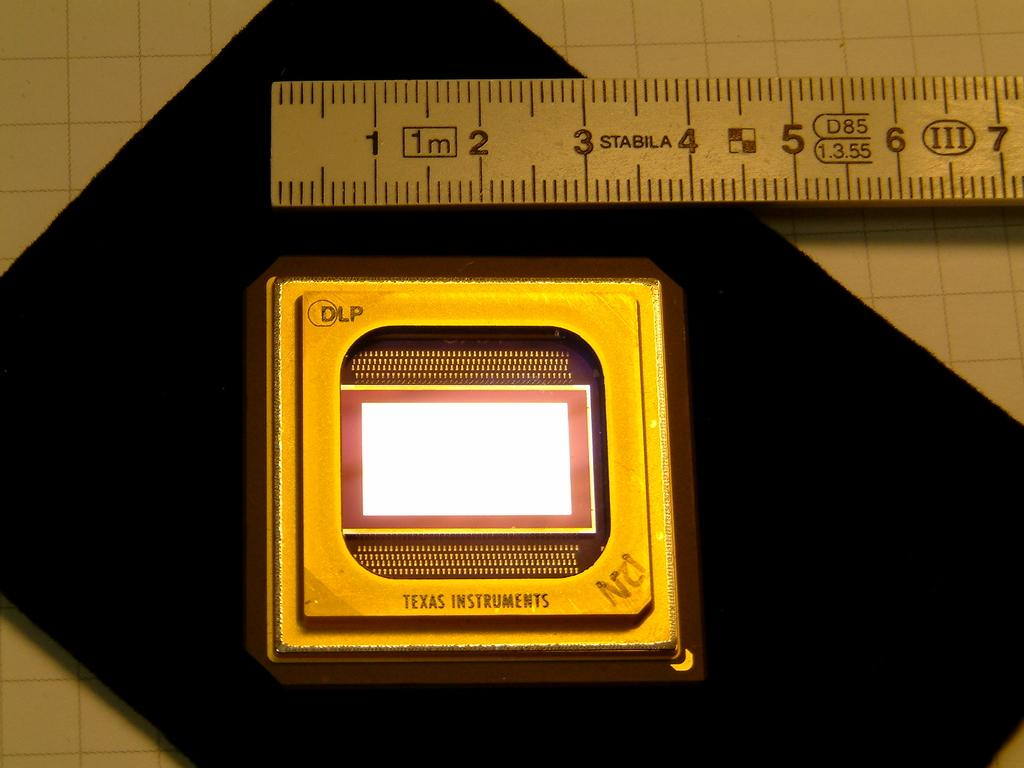<image>
Relay a brief, clear account of the picture shown. A square chip from Texas Instrument is about 3.5 mm in length. 